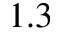<formula> <loc_0><loc_0><loc_500><loc_500>1 . 3</formula> 